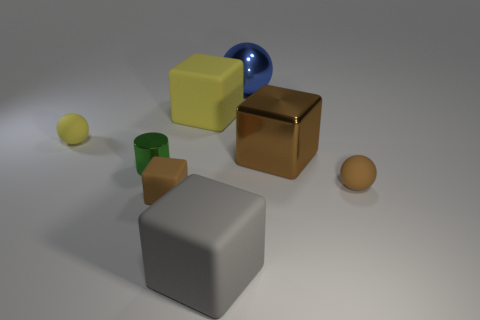Is there a big cube of the same color as the small cube?
Provide a succinct answer. Yes. What is the color of the big rubber object right of the big matte block behind the tiny cylinder?
Provide a succinct answer. Gray. Are there fewer big metallic things right of the large blue metallic sphere than shiny cylinders that are behind the large brown metallic thing?
Your answer should be compact. No. Does the gray block have the same size as the green object?
Your answer should be compact. No. There is a tiny matte object that is to the left of the large blue metal thing and behind the tiny block; what shape is it?
Provide a short and direct response. Sphere. How many big brown cylinders are made of the same material as the big blue thing?
Provide a succinct answer. 0. What number of cubes are to the right of the gray rubber block that is on the left side of the big brown metallic object?
Offer a terse response. 1. What is the shape of the thing that is in front of the small brown object that is on the left side of the metallic sphere behind the small green metallic thing?
Offer a terse response. Cube. What size is the other block that is the same color as the metallic cube?
Provide a short and direct response. Small. What number of things are either tiny green rubber objects or small shiny things?
Keep it short and to the point. 1. 